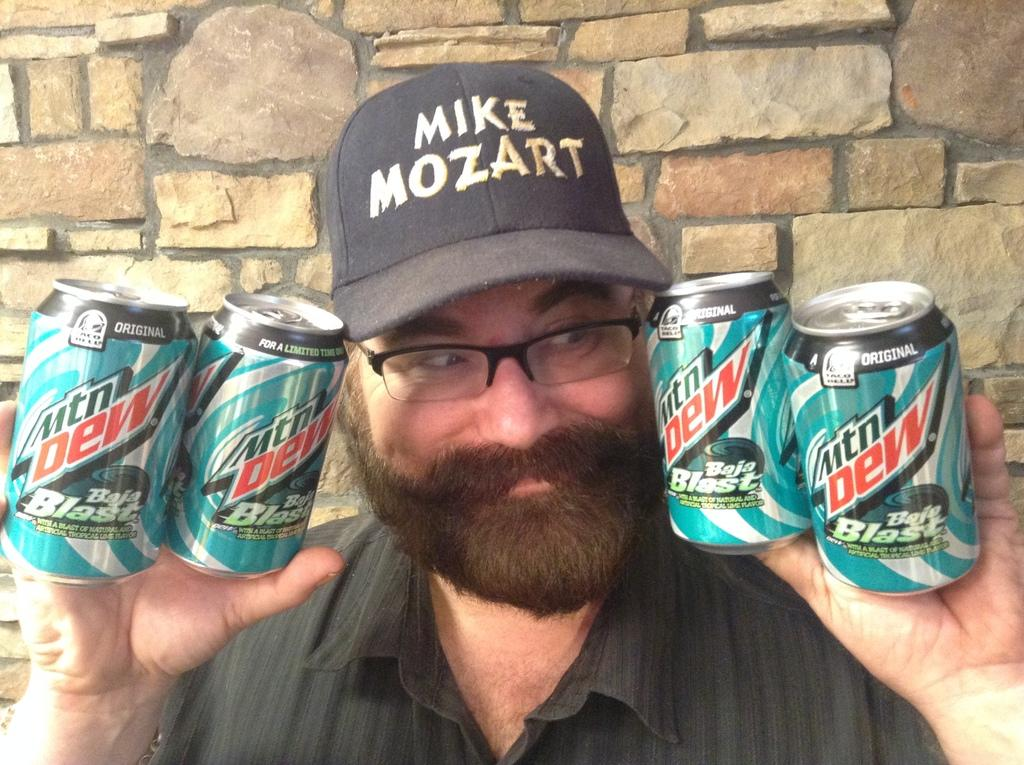<image>
Describe the image concisely. A man wearing a Mike Mozart hat is holdng four cans of Mtn Dew Baja Blast. 